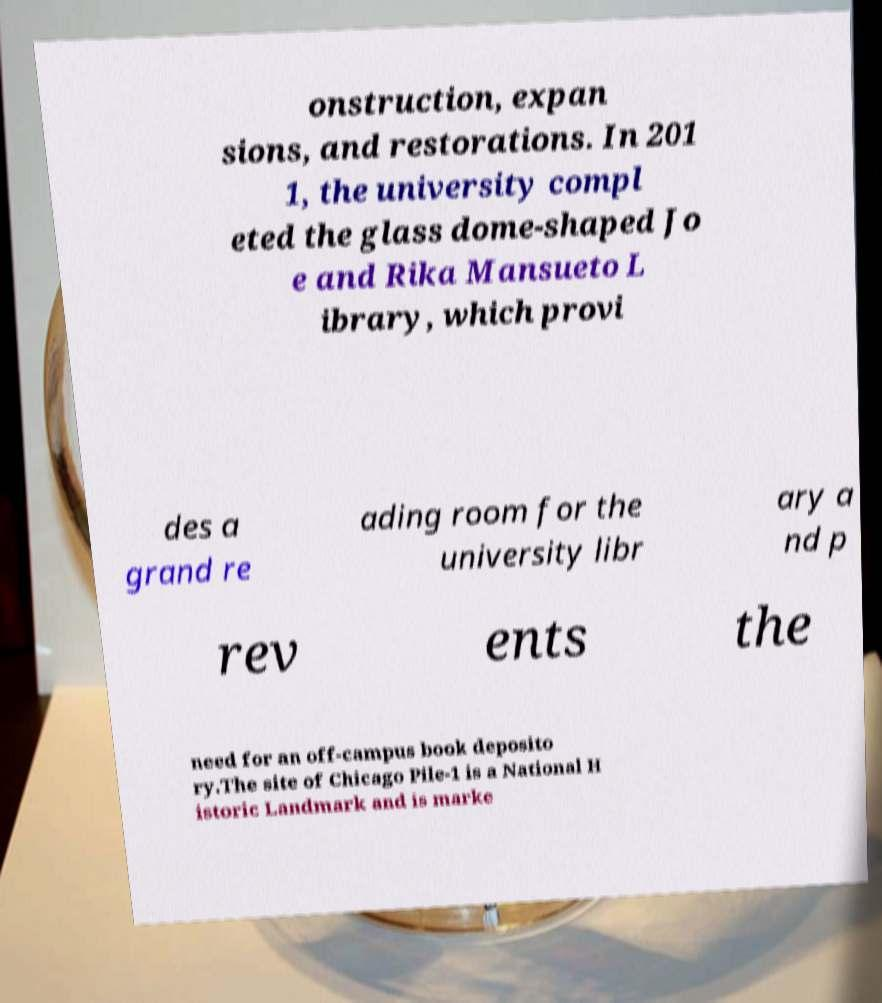Can you read and provide the text displayed in the image?This photo seems to have some interesting text. Can you extract and type it out for me? onstruction, expan sions, and restorations. In 201 1, the university compl eted the glass dome-shaped Jo e and Rika Mansueto L ibrary, which provi des a grand re ading room for the university libr ary a nd p rev ents the need for an off-campus book deposito ry.The site of Chicago Pile-1 is a National H istoric Landmark and is marke 